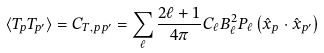<formula> <loc_0><loc_0><loc_500><loc_500>\langle T _ { p } T _ { p ^ { \prime } } \rangle = C _ { T , p p ^ { \prime } } = \sum _ { \ell } \frac { 2 \ell + 1 } { 4 \pi } C _ { \ell } B _ { \ell } ^ { 2 } P _ { \ell } \left ( { \hat { x } } _ { p } \cdot { \hat { x } } _ { p ^ { \prime } } \right )</formula> 